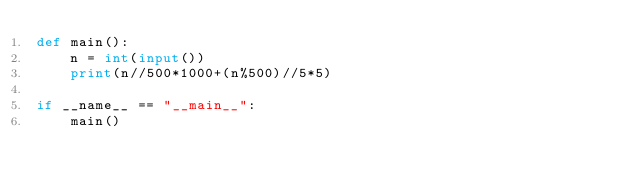<code> <loc_0><loc_0><loc_500><loc_500><_Python_>def main():
    n = int(input())
    print(n//500*1000+(n%500)//5*5)

if __name__ == "__main__":
    main()</code> 